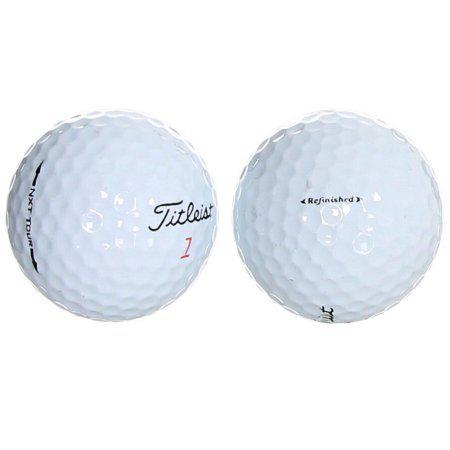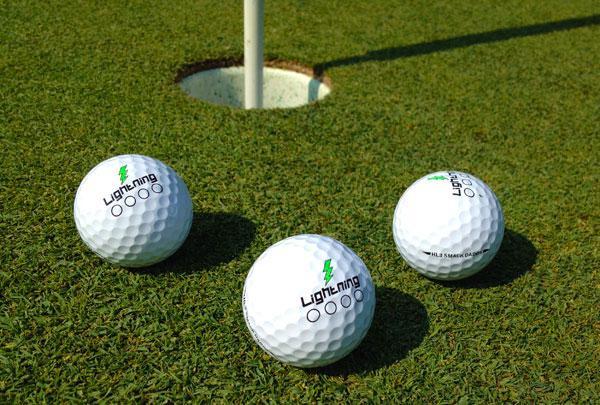The first image is the image on the left, the second image is the image on the right. Given the left and right images, does the statement "The balls in the image on the left are on the grass." hold true? Answer yes or no. No. The first image is the image on the left, the second image is the image on the right. Analyze the images presented: Is the assertion "An image shows at least one golf ball on the green ground near a hole." valid? Answer yes or no. Yes. 